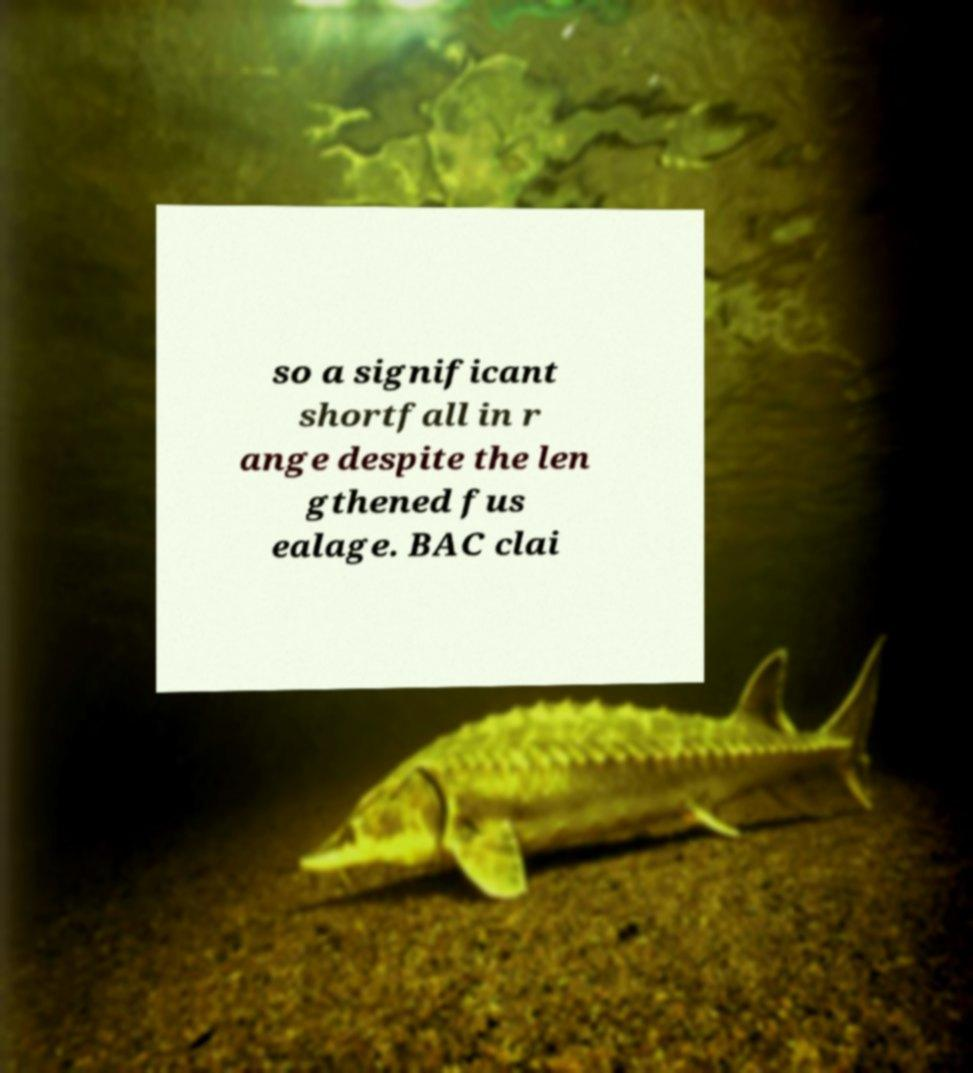What messages or text are displayed in this image? I need them in a readable, typed format. so a significant shortfall in r ange despite the len gthened fus ealage. BAC clai 